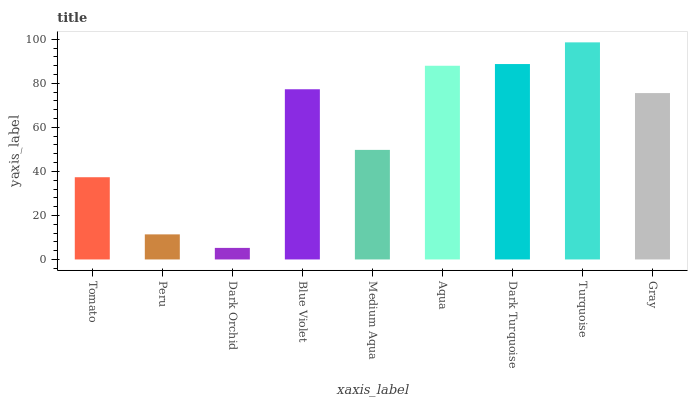Is Dark Orchid the minimum?
Answer yes or no. Yes. Is Turquoise the maximum?
Answer yes or no. Yes. Is Peru the minimum?
Answer yes or no. No. Is Peru the maximum?
Answer yes or no. No. Is Tomato greater than Peru?
Answer yes or no. Yes. Is Peru less than Tomato?
Answer yes or no. Yes. Is Peru greater than Tomato?
Answer yes or no. No. Is Tomato less than Peru?
Answer yes or no. No. Is Gray the high median?
Answer yes or no. Yes. Is Gray the low median?
Answer yes or no. Yes. Is Peru the high median?
Answer yes or no. No. Is Blue Violet the low median?
Answer yes or no. No. 